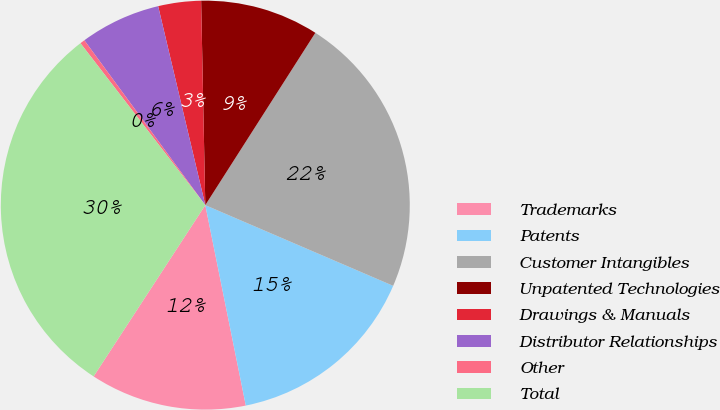Convert chart to OTSL. <chart><loc_0><loc_0><loc_500><loc_500><pie_chart><fcel>Trademarks<fcel>Patents<fcel>Customer Intangibles<fcel>Unpatented Technologies<fcel>Drawings & Manuals<fcel>Distributor Relationships<fcel>Other<fcel>Total<nl><fcel>12.37%<fcel>15.37%<fcel>22.41%<fcel>9.37%<fcel>3.38%<fcel>6.37%<fcel>0.38%<fcel>30.35%<nl></chart> 